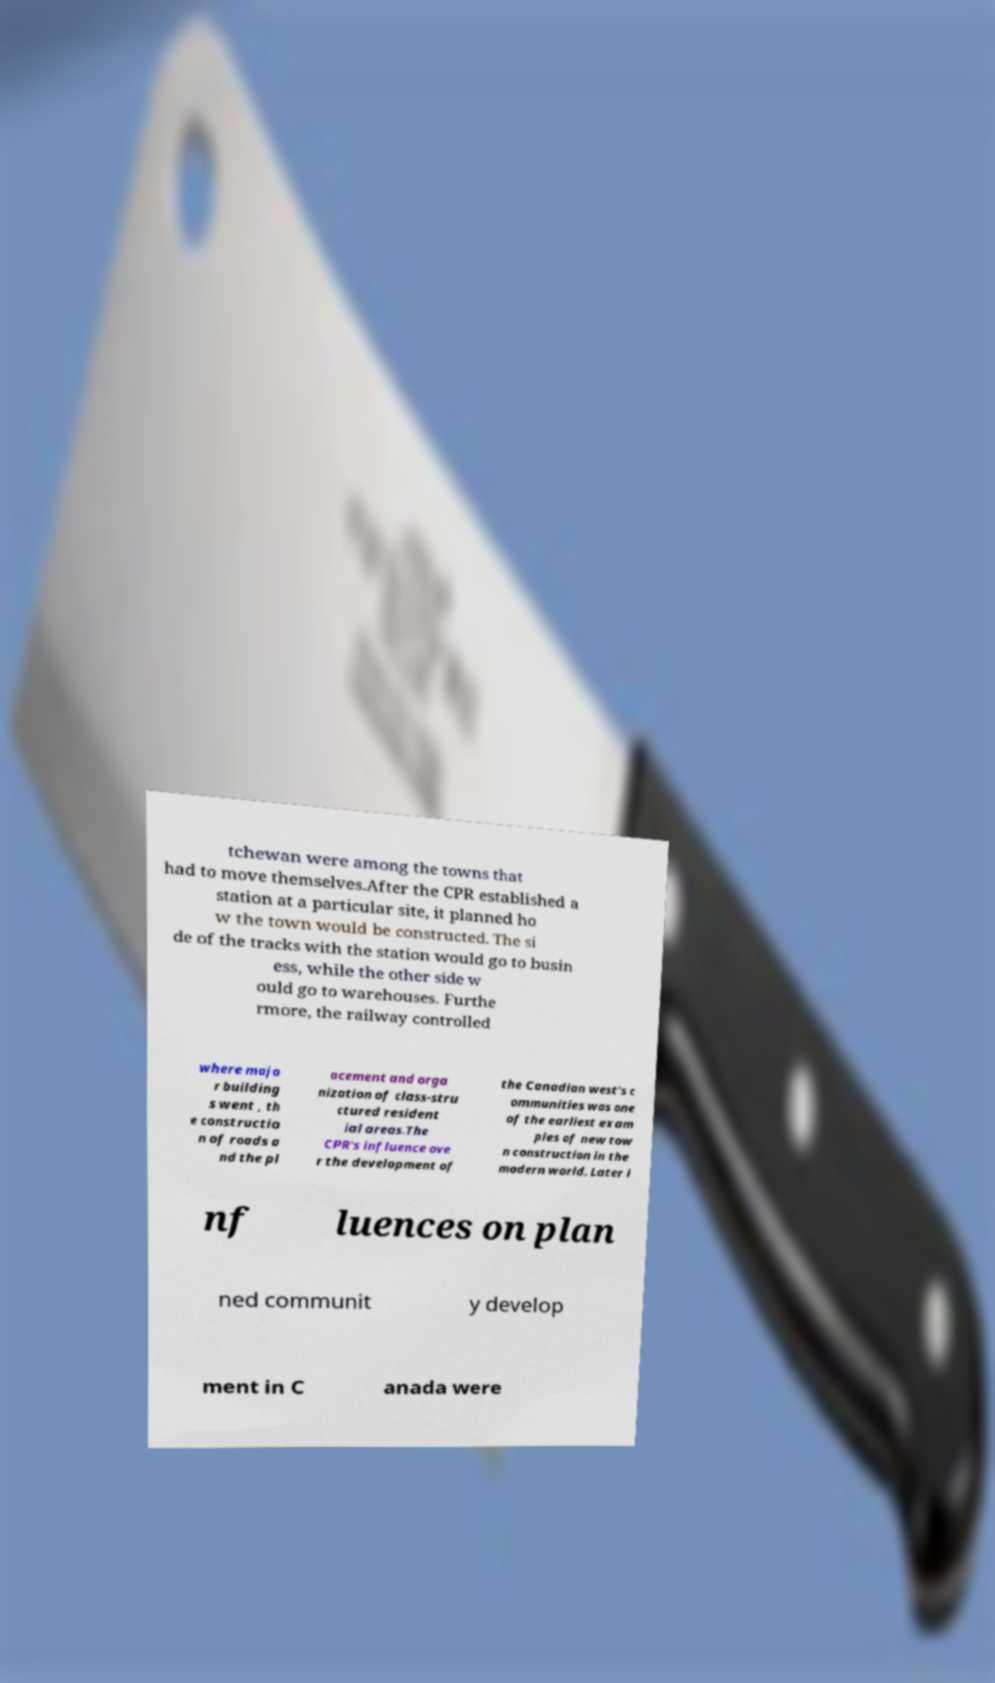What messages or text are displayed in this image? I need them in a readable, typed format. tchewan were among the towns that had to move themselves.After the CPR established a station at a particular site, it planned ho w the town would be constructed. The si de of the tracks with the station would go to busin ess, while the other side w ould go to warehouses. Furthe rmore, the railway controlled where majo r building s went , th e constructio n of roads a nd the pl acement and orga nization of class-stru ctured resident ial areas.The CPR's influence ove r the development of the Canadian west's c ommunities was one of the earliest exam ples of new tow n construction in the modern world. Later i nf luences on plan ned communit y develop ment in C anada were 